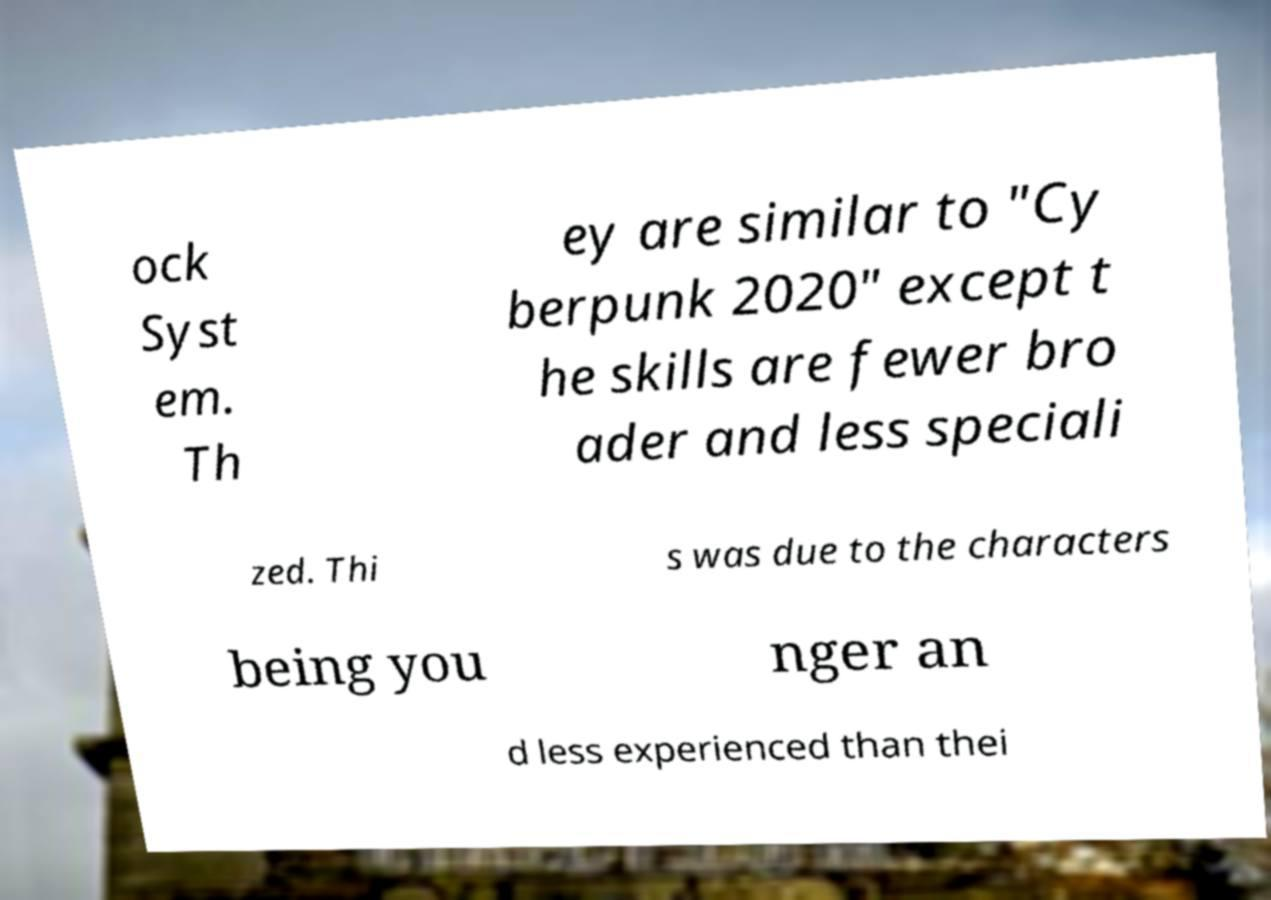Could you assist in decoding the text presented in this image and type it out clearly? ock Syst em. Th ey are similar to "Cy berpunk 2020" except t he skills are fewer bro ader and less speciali zed. Thi s was due to the characters being you nger an d less experienced than thei 